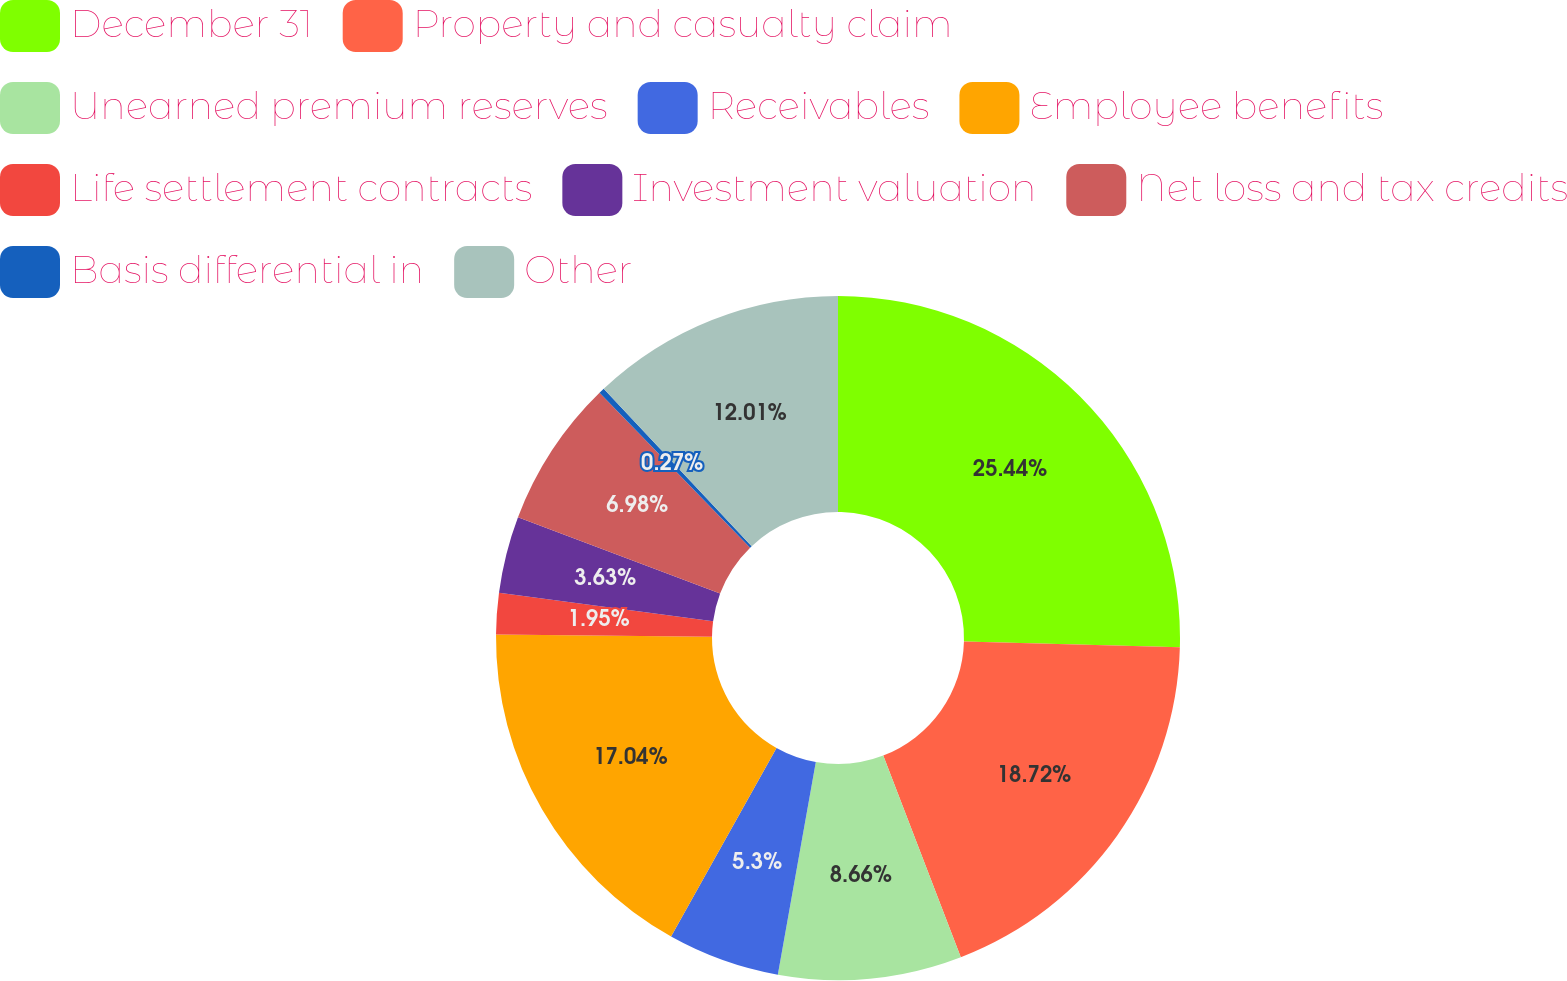Convert chart. <chart><loc_0><loc_0><loc_500><loc_500><pie_chart><fcel>December 31<fcel>Property and casualty claim<fcel>Unearned premium reserves<fcel>Receivables<fcel>Employee benefits<fcel>Life settlement contracts<fcel>Investment valuation<fcel>Net loss and tax credits<fcel>Basis differential in<fcel>Other<nl><fcel>25.43%<fcel>18.72%<fcel>8.66%<fcel>5.3%<fcel>17.04%<fcel>1.95%<fcel>3.63%<fcel>6.98%<fcel>0.27%<fcel>12.01%<nl></chart> 